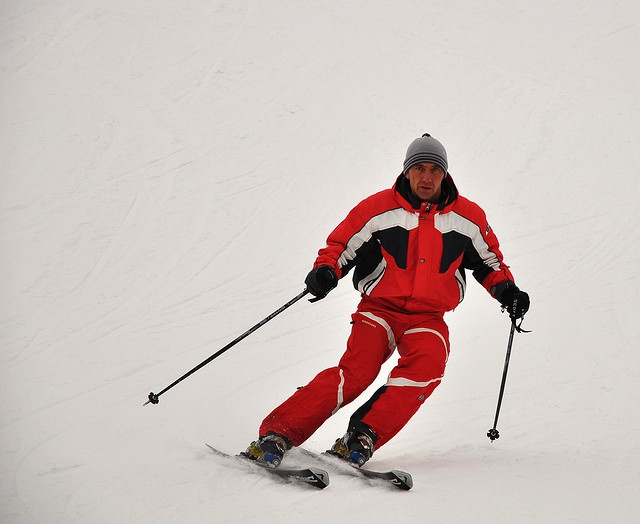Describe the objects in this image and their specific colors. I can see people in darkgray, brown, black, and maroon tones and skis in darkgray, gray, black, and lightgray tones in this image. 